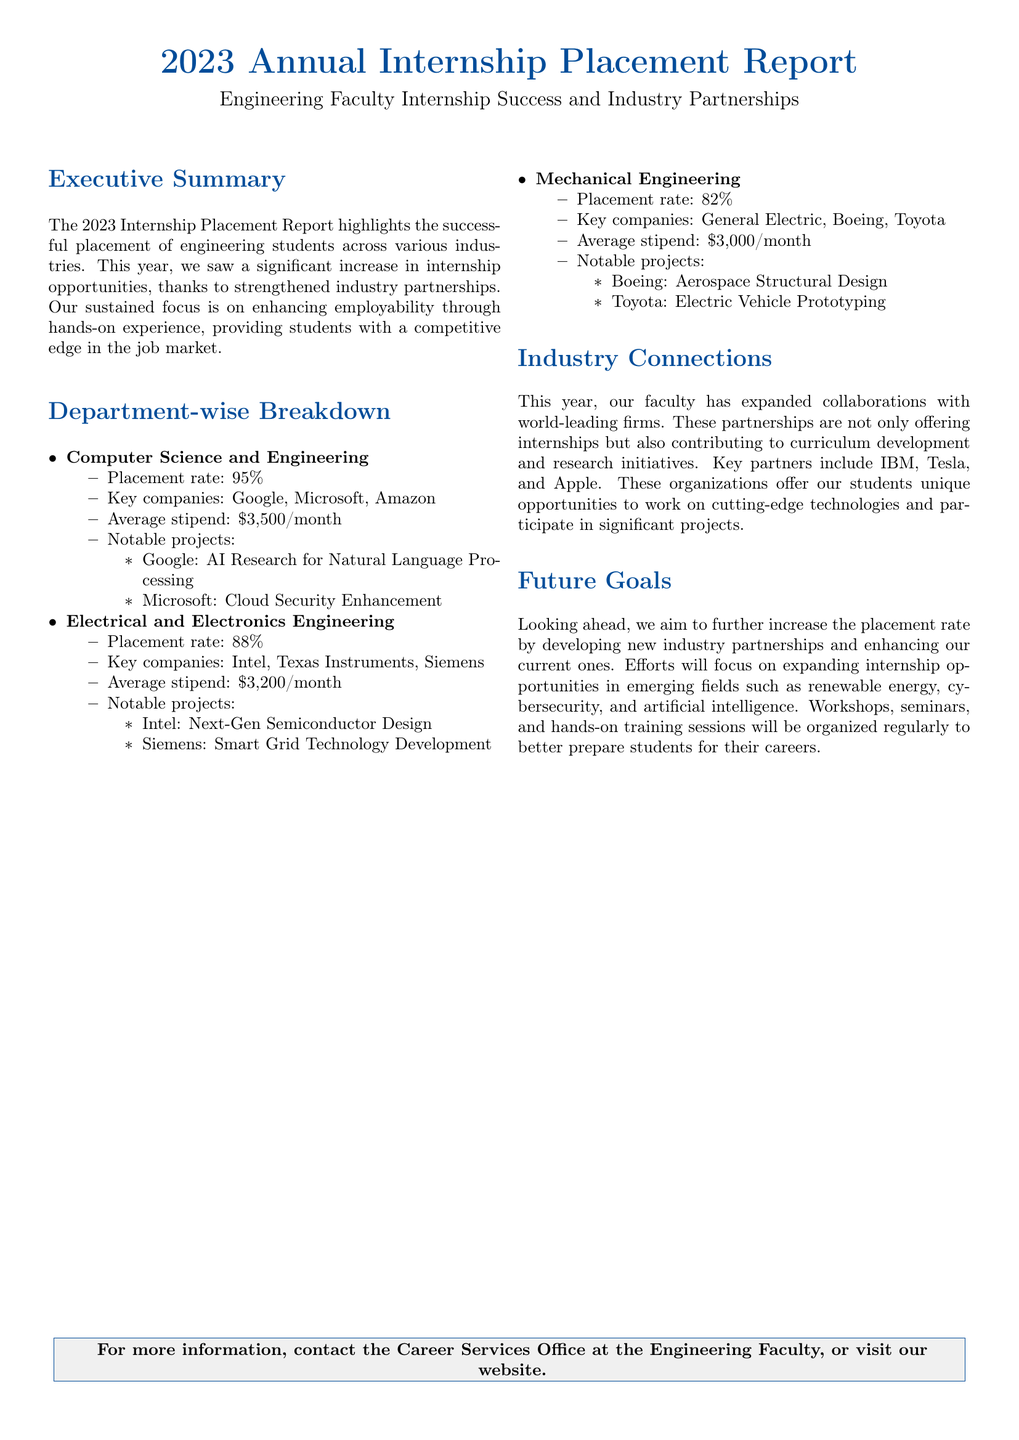what is the placement rate for Computer Science and Engineering? The placement rate for Computer Science and Engineering is found in the Department-wise Breakdown, showing a placement rate of 95%.
Answer: 95% what is the average stipend for Electrical and Electronics Engineering students? The average stipend for Electrical and Electronics Engineering students is detailed in the Department-wise Breakdown, which states it is $3,200/month.
Answer: $3,200/month which company is associated with the project on Smart Grid Technology Development? The project on Smart Grid Technology Development is linked to Siemens, as mentioned in the notable projects for Electrical and Electronics Engineering.
Answer: Siemens how many key companies are listed for Mechanical Engineering? The key companies listed for Mechanical Engineering can be counted in the Department-wise Breakdown, with three companies reported: General Electric, Boeing, and Toyota.
Answer: 3 which industry partners are mentioned in the Industry Connections section? The Industry Connections section lists IBM, Tesla, and Apple as key partners that provide internship opportunities.
Answer: IBM, Tesla, Apple what is the placement rate for Mechanical Engineering? The placement rate specifically for Mechanical Engineering is stated in the Department-wise Breakdown, indicating an 82% placement rate.
Answer: 82% which emerging fields are targeted for future internship opportunities? The Future Goals section outlines emerging fields for future internships, specifically mentioning renewable energy, cybersecurity, and artificial intelligence.
Answer: renewable energy, cybersecurity, artificial intelligence how many departments are covered in the Department-wise Breakdown? The Department-wise Breakdown details three departments, including Computer Science and Engineering, Electrical and Electronics Engineering, and Mechanical Engineering.
Answer: 3 